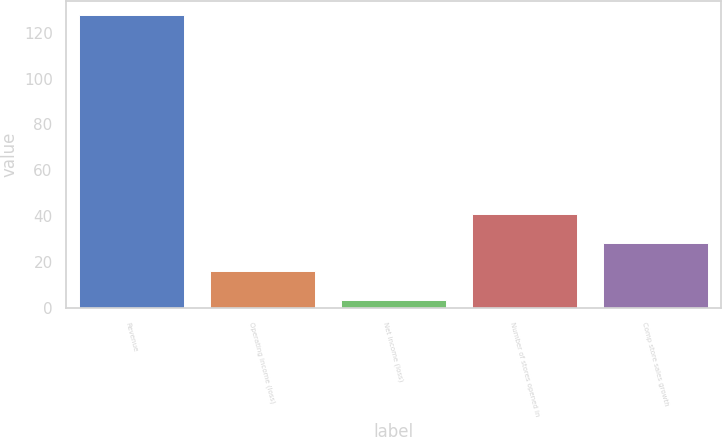Convert chart. <chart><loc_0><loc_0><loc_500><loc_500><bar_chart><fcel>Revenue<fcel>Operating income (loss)<fcel>Net income (loss)<fcel>Number of stores opened in<fcel>Comp store sales growth<nl><fcel>127.5<fcel>16.08<fcel>3.7<fcel>40.84<fcel>28.46<nl></chart> 